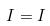<formula> <loc_0><loc_0><loc_500><loc_500>I = I</formula> 